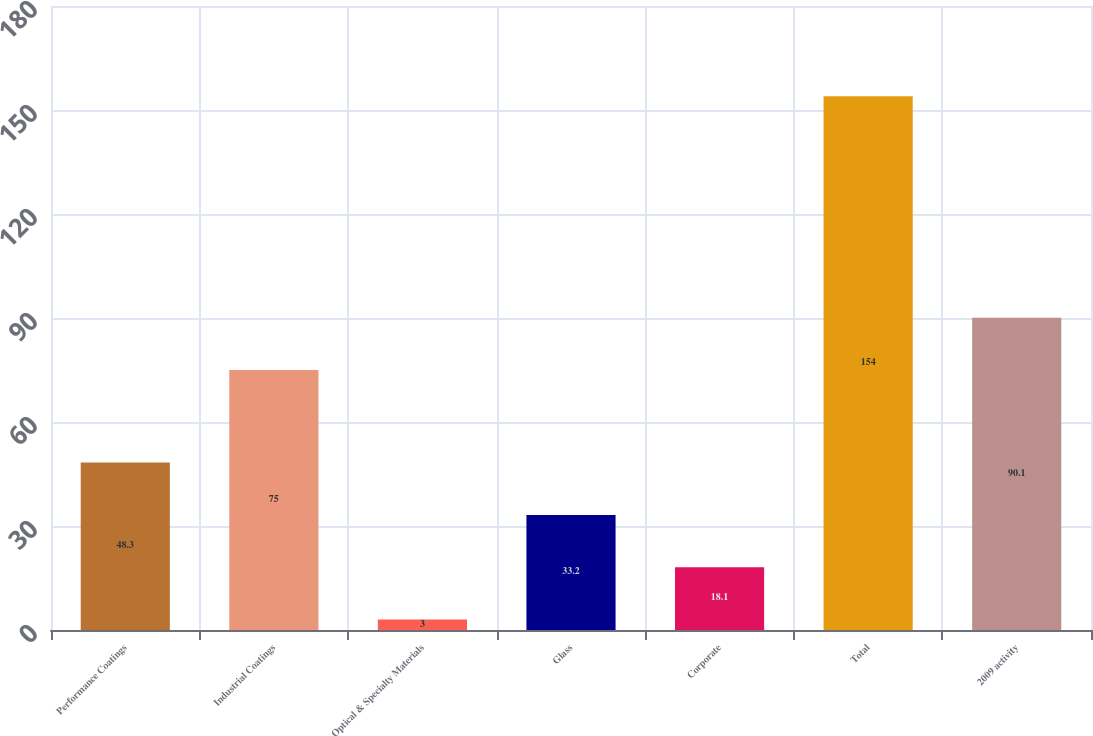Convert chart to OTSL. <chart><loc_0><loc_0><loc_500><loc_500><bar_chart><fcel>Performance Coatings<fcel>Industrial Coatings<fcel>Optical & Specialty Materials<fcel>Glass<fcel>Corporate<fcel>Total<fcel>2009 activity<nl><fcel>48.3<fcel>75<fcel>3<fcel>33.2<fcel>18.1<fcel>154<fcel>90.1<nl></chart> 